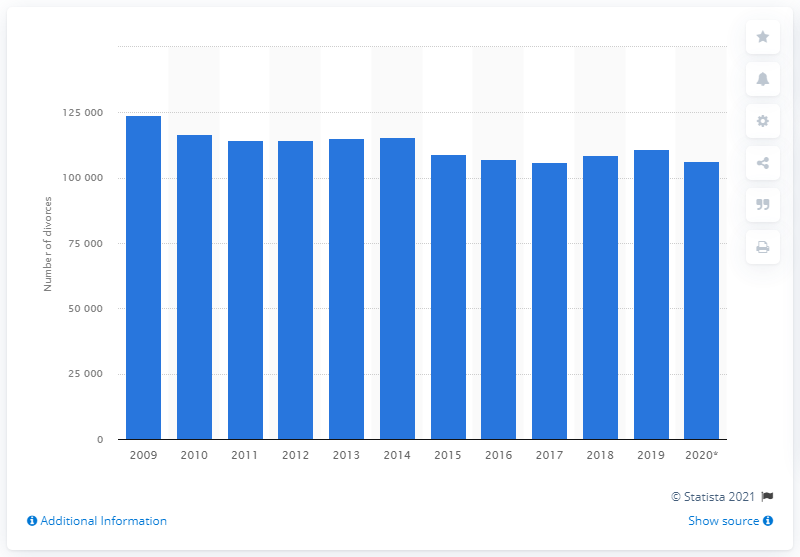List a handful of essential elements in this visual. According to recent statistics, in 2020 there were a total of 106,500 divorces in South Korea. 